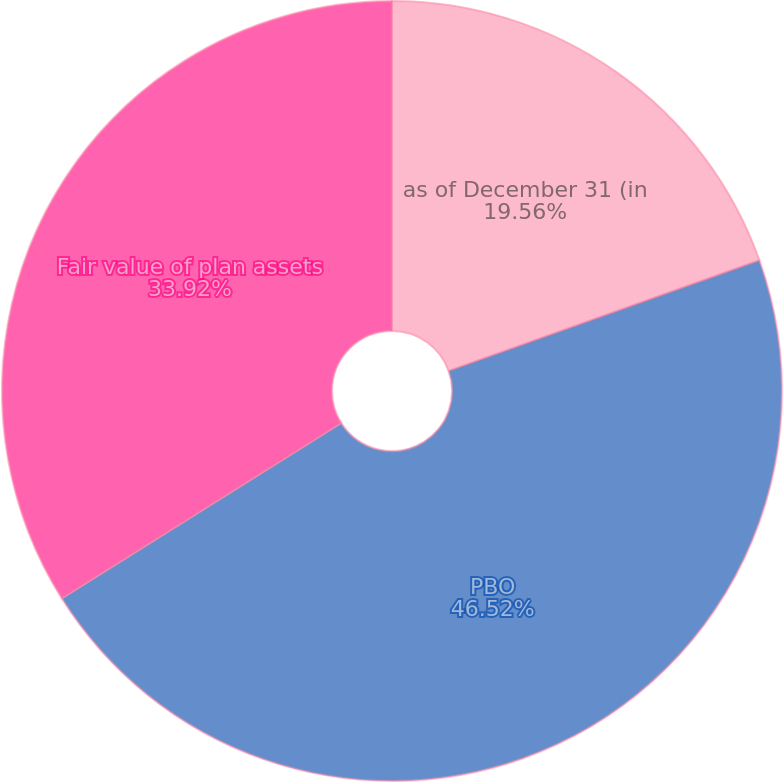<chart> <loc_0><loc_0><loc_500><loc_500><pie_chart><fcel>as of December 31 (in<fcel>PBO<fcel>Fair value of plan assets<nl><fcel>19.56%<fcel>46.52%<fcel>33.92%<nl></chart> 